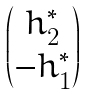<formula> <loc_0><loc_0><loc_500><loc_500>\begin{pmatrix} h _ { 2 } ^ { * } \\ - h ^ { * } _ { 1 } \end{pmatrix}</formula> 